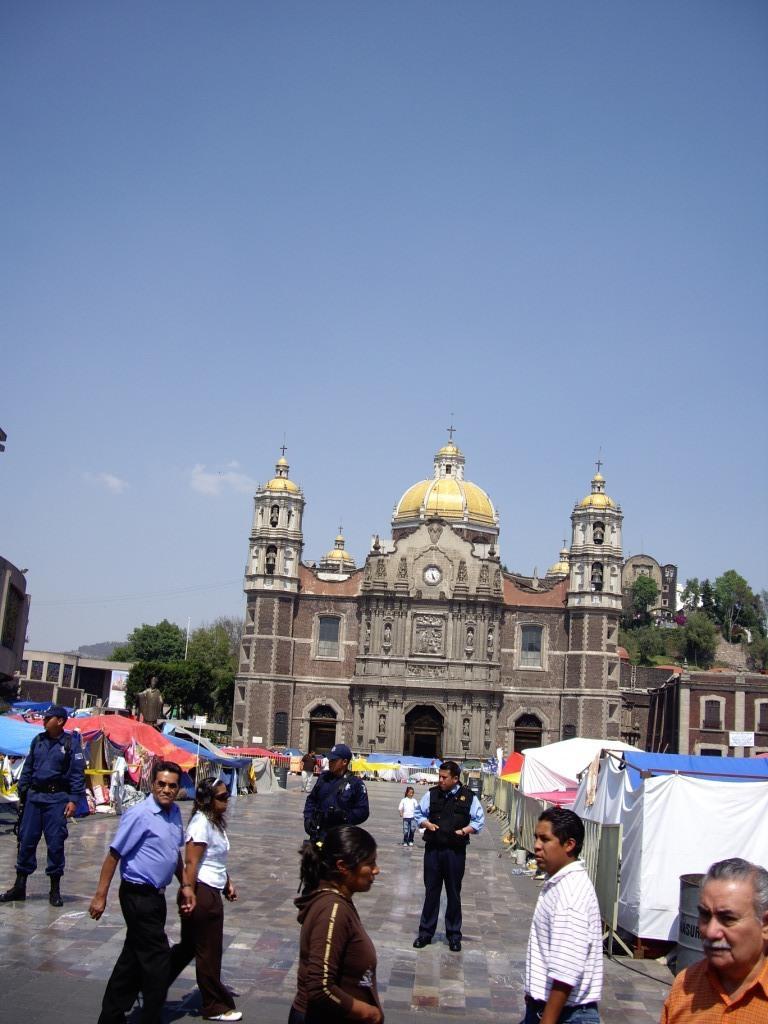In one or two sentences, can you explain what this image depicts? In this image we can see the buildings, in front of the building we can see there are people walking on the floor and we can see there are tents. In the background, we can see the sky and trees. 